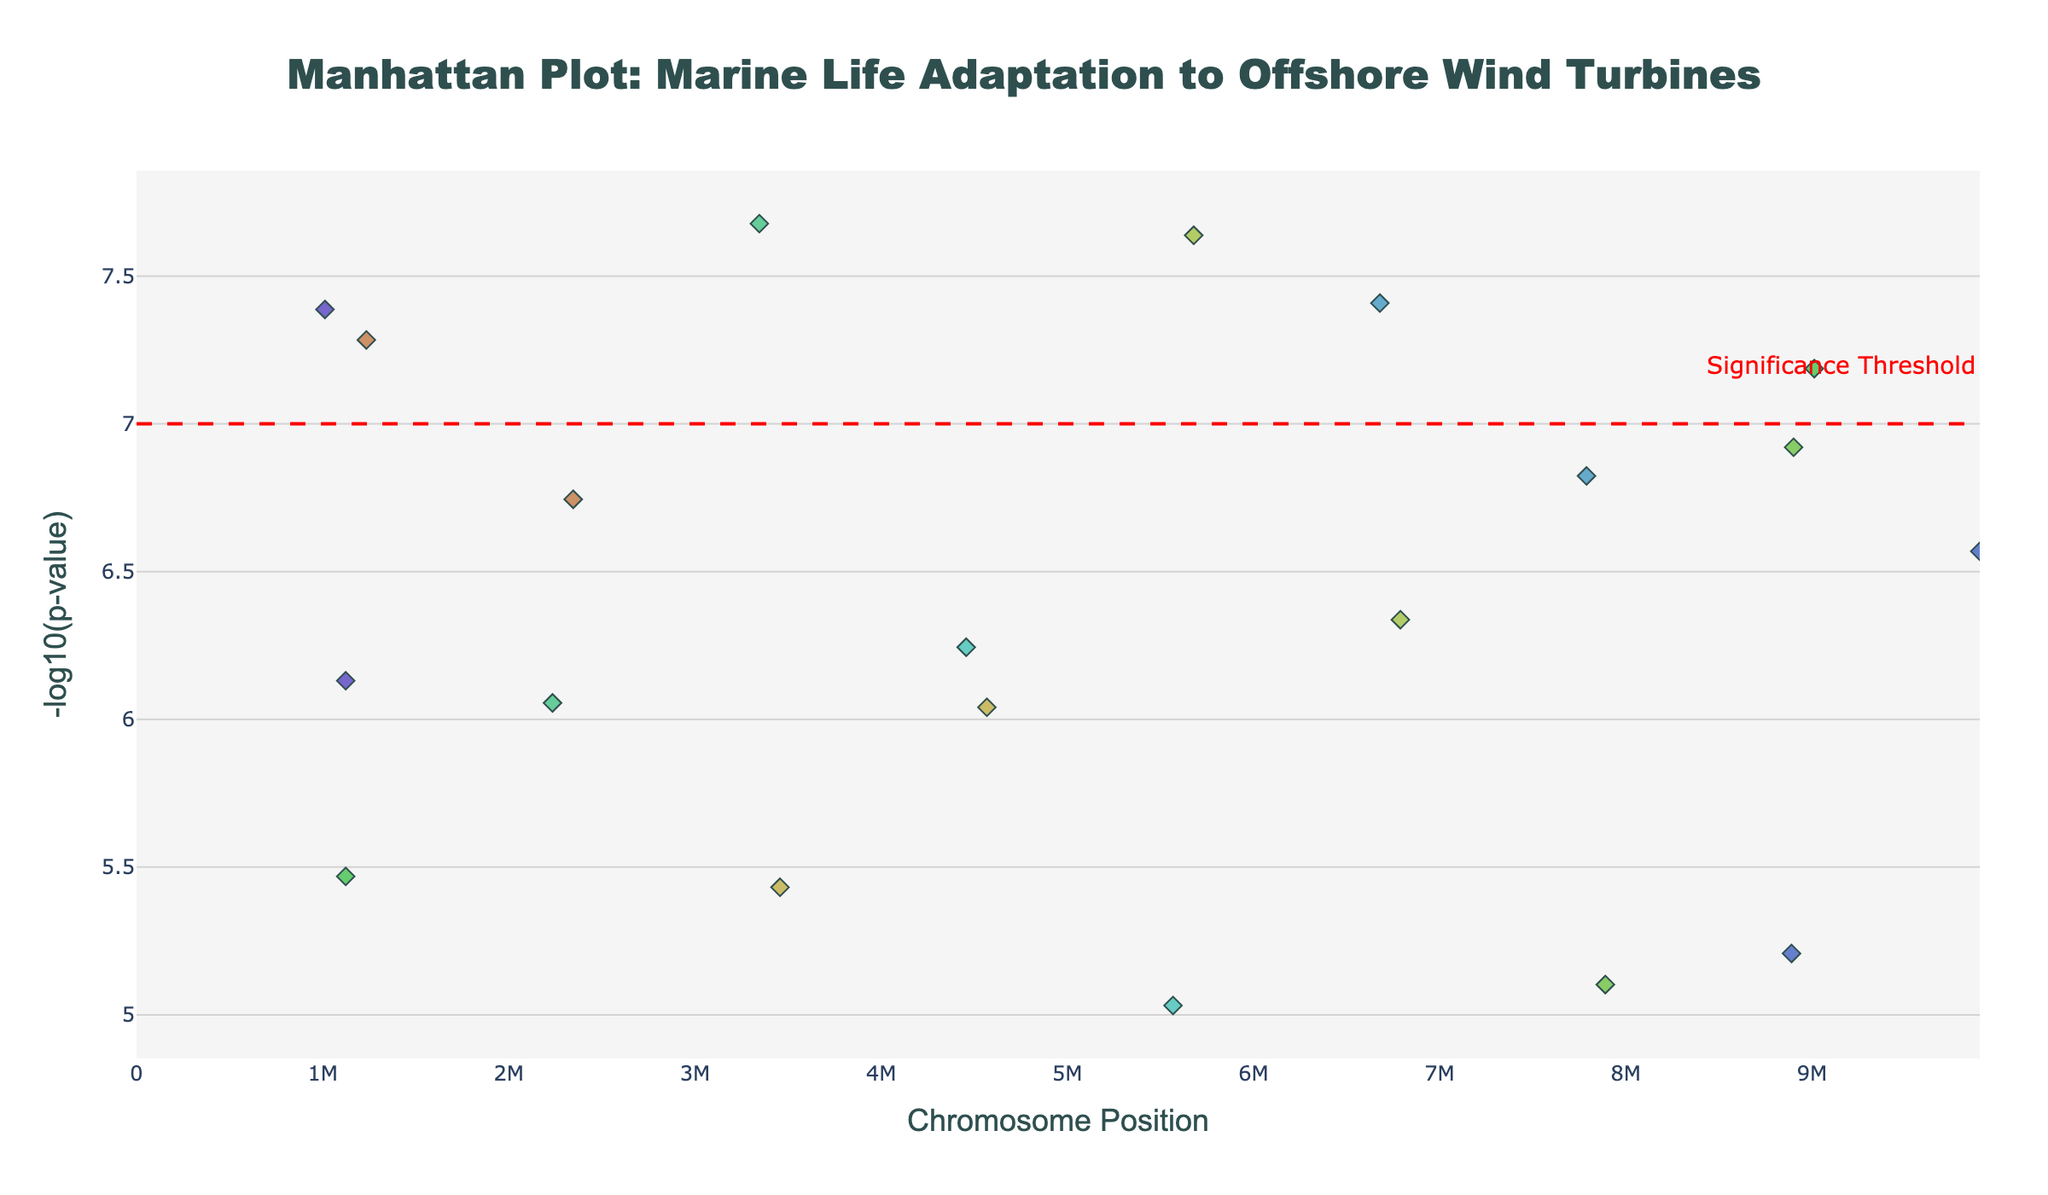What is the title of the plot? The title of the plot is displayed at the top center, indicating what the plot represents.
Answer: Manhattan Plot: Marine Life Adaptation to Offshore Wind Turbines Which chromosome has the highest point in the plot? By locating the highest point on the y-axis and checking the corresponding chromosome marker (color-coded and named), we determine which chromosome it belongs to.
Answer: Chromosome 3 What gene corresponds to the most significant p-value? The most significant p-value is the point with the highest -log10(p) value. By checking the hover information on that point, we can see the gene name.
Answer: MT-CO1 Which chromosome shows the most data points above the significance threshold line? Observing which chromosome has the most points above the red dashed line at y=7 by comparing each colored group in the plot.
Answer: Chromosome 1 What is the significance threshold set in the plot? There's a horizontal red dashed line in the plot with an annotation text, indicating the significance threshold value.
Answer: 7 How many genes have p-values more significant than the threshold? Count all the points whose -log10(p) values are higher than the significance threshold line set at y=7.
Answer: 4 Which gene on Chromosome 10 has a significant p-value? Inspect the points specifically on Chromosome 10 and find the ones above the significance threshold line, then identify the gene from the hover information.
Answer: CASP3 Compare the significance levels of genes on Chromosome 5. Which is more significant, GPX1 or TNF? For genes on Chromosome 5, compare their -log10(p) values. A higher value indicates a more significant p-value.
Answer: GPX1 What is the -log10(p) value for the gene VEGF on Chromosome 10? Hover over the point corresponding to the gene VEGF on Chromosome 10 and check the hover information for its -log10(p) value.
Answer: Approximately 6.13 Which genes are found on Chromosome 2? Look for all points color-coded for Chromosome 2 and check their hover information for the gene names.
Answer: HSP70, CYP1A 